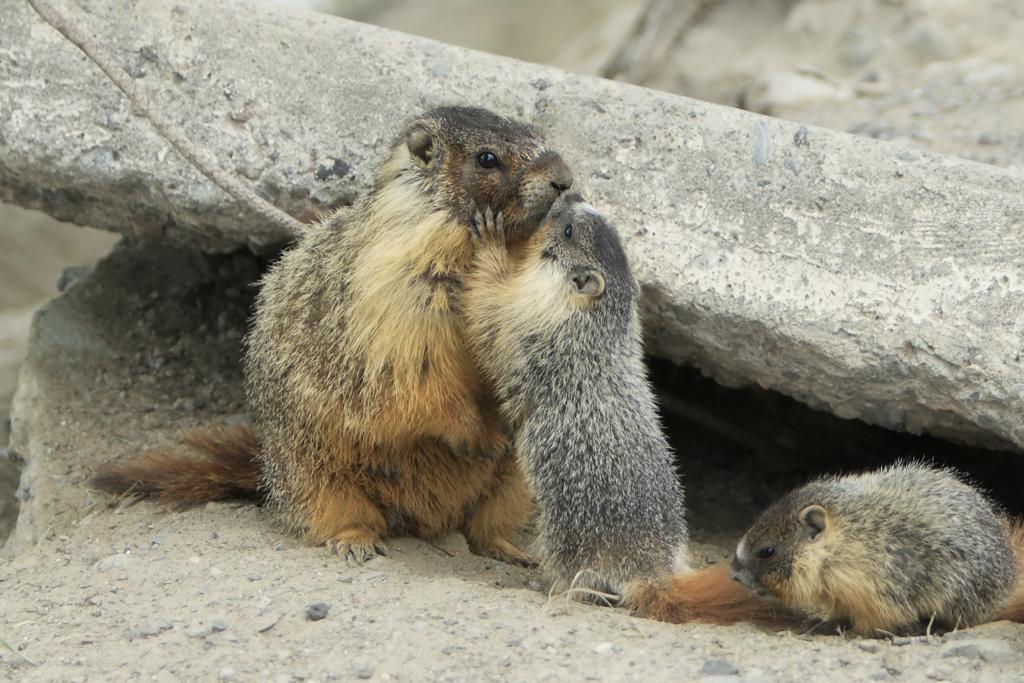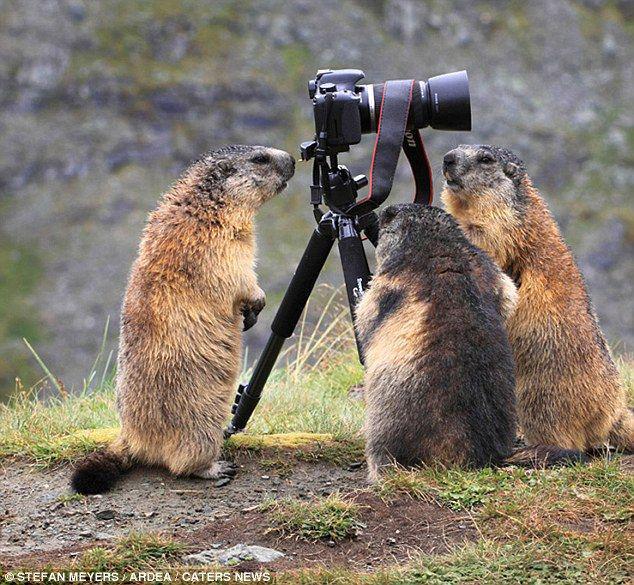The first image is the image on the left, the second image is the image on the right. Evaluate the accuracy of this statement regarding the images: "Left image contains two marmots, which are upright and posed together, and the one on the left of the picture looks shorter than the marmot on the right.". Is it true? Answer yes or no. No. The first image is the image on the left, the second image is the image on the right. Analyze the images presented: Is the assertion "The animals in the image on the right are standing on their hind legs." valid? Answer yes or no. Yes. 